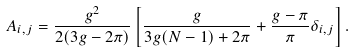Convert formula to latex. <formula><loc_0><loc_0><loc_500><loc_500>A _ { i , j } = \frac { g ^ { 2 } } { 2 ( 3 g - 2 \pi ) } \left [ \frac { g } { 3 g ( N - 1 ) + 2 \pi } + \frac { g - \pi } { \pi } \delta _ { i , j } \right ] .</formula> 